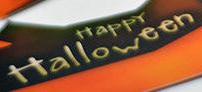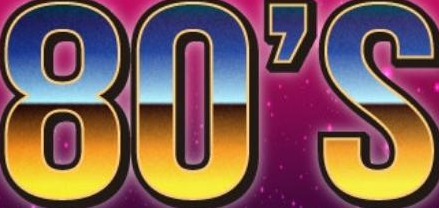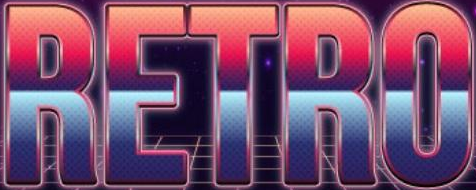What words can you see in these images in sequence, separated by a semicolon? Halloween; 80'S; RETRO 